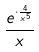<formula> <loc_0><loc_0><loc_500><loc_500>\frac { e ^ { \cdot \frac { 4 } { x ^ { 5 } } } } { x }</formula> 